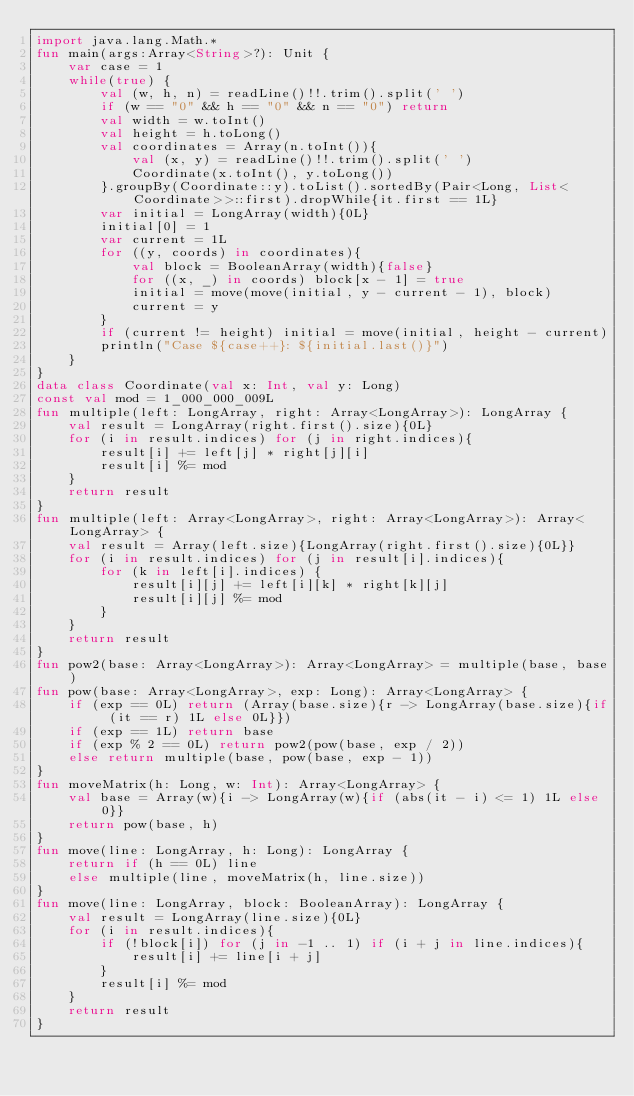<code> <loc_0><loc_0><loc_500><loc_500><_Kotlin_>import java.lang.Math.*
fun main(args:Array<String>?): Unit {
    var case = 1
    while(true) {
        val (w, h, n) = readLine()!!.trim().split(' ')
        if (w == "0" && h == "0" && n == "0") return
        val width = w.toInt()
        val height = h.toLong()
        val coordinates = Array(n.toInt()){
            val (x, y) = readLine()!!.trim().split(' ')
            Coordinate(x.toInt(), y.toLong())
        }.groupBy(Coordinate::y).toList().sortedBy(Pair<Long, List<Coordinate>>::first).dropWhile{it.first == 1L}
        var initial = LongArray(width){0L}
        initial[0] = 1
        var current = 1L
        for ((y, coords) in coordinates){
            val block = BooleanArray(width){false}
            for ((x, _) in coords) block[x - 1] = true
            initial = move(move(initial, y - current - 1), block)
            current = y
        }
        if (current != height) initial = move(initial, height - current)
        println("Case ${case++}: ${initial.last()}")
    }
}
data class Coordinate(val x: Int, val y: Long)
const val mod = 1_000_000_009L
fun multiple(left: LongArray, right: Array<LongArray>): LongArray {
    val result = LongArray(right.first().size){0L}
    for (i in result.indices) for (j in right.indices){
        result[i] += left[j] * right[j][i]
        result[i] %= mod
    }
    return result
}
fun multiple(left: Array<LongArray>, right: Array<LongArray>): Array<LongArray> {
    val result = Array(left.size){LongArray(right.first().size){0L}}
    for (i in result.indices) for (j in result[i].indices){
        for (k in left[i].indices) {
            result[i][j] += left[i][k] * right[k][j]
            result[i][j] %= mod
        }
    }
    return result
}
fun pow2(base: Array<LongArray>): Array<LongArray> = multiple(base, base)
fun pow(base: Array<LongArray>, exp: Long): Array<LongArray> {
    if (exp == 0L) return (Array(base.size){r -> LongArray(base.size){if (it == r) 1L else 0L}})
    if (exp == 1L) return base
    if (exp % 2 == 0L) return pow2(pow(base, exp / 2))
    else return multiple(base, pow(base, exp - 1))
}
fun moveMatrix(h: Long, w: Int): Array<LongArray> {
    val base = Array(w){i -> LongArray(w){if (abs(it - i) <= 1) 1L else 0}}
    return pow(base, h)
}
fun move(line: LongArray, h: Long): LongArray {
    return if (h == 0L) line
    else multiple(line, moveMatrix(h, line.size))
}
fun move(line: LongArray, block: BooleanArray): LongArray {
    val result = LongArray(line.size){0L}
    for (i in result.indices){
        if (!block[i]) for (j in -1 .. 1) if (i + j in line.indices){
            result[i] += line[i + j]
        }
        result[i] %= mod
    }
    return result
}
</code> 